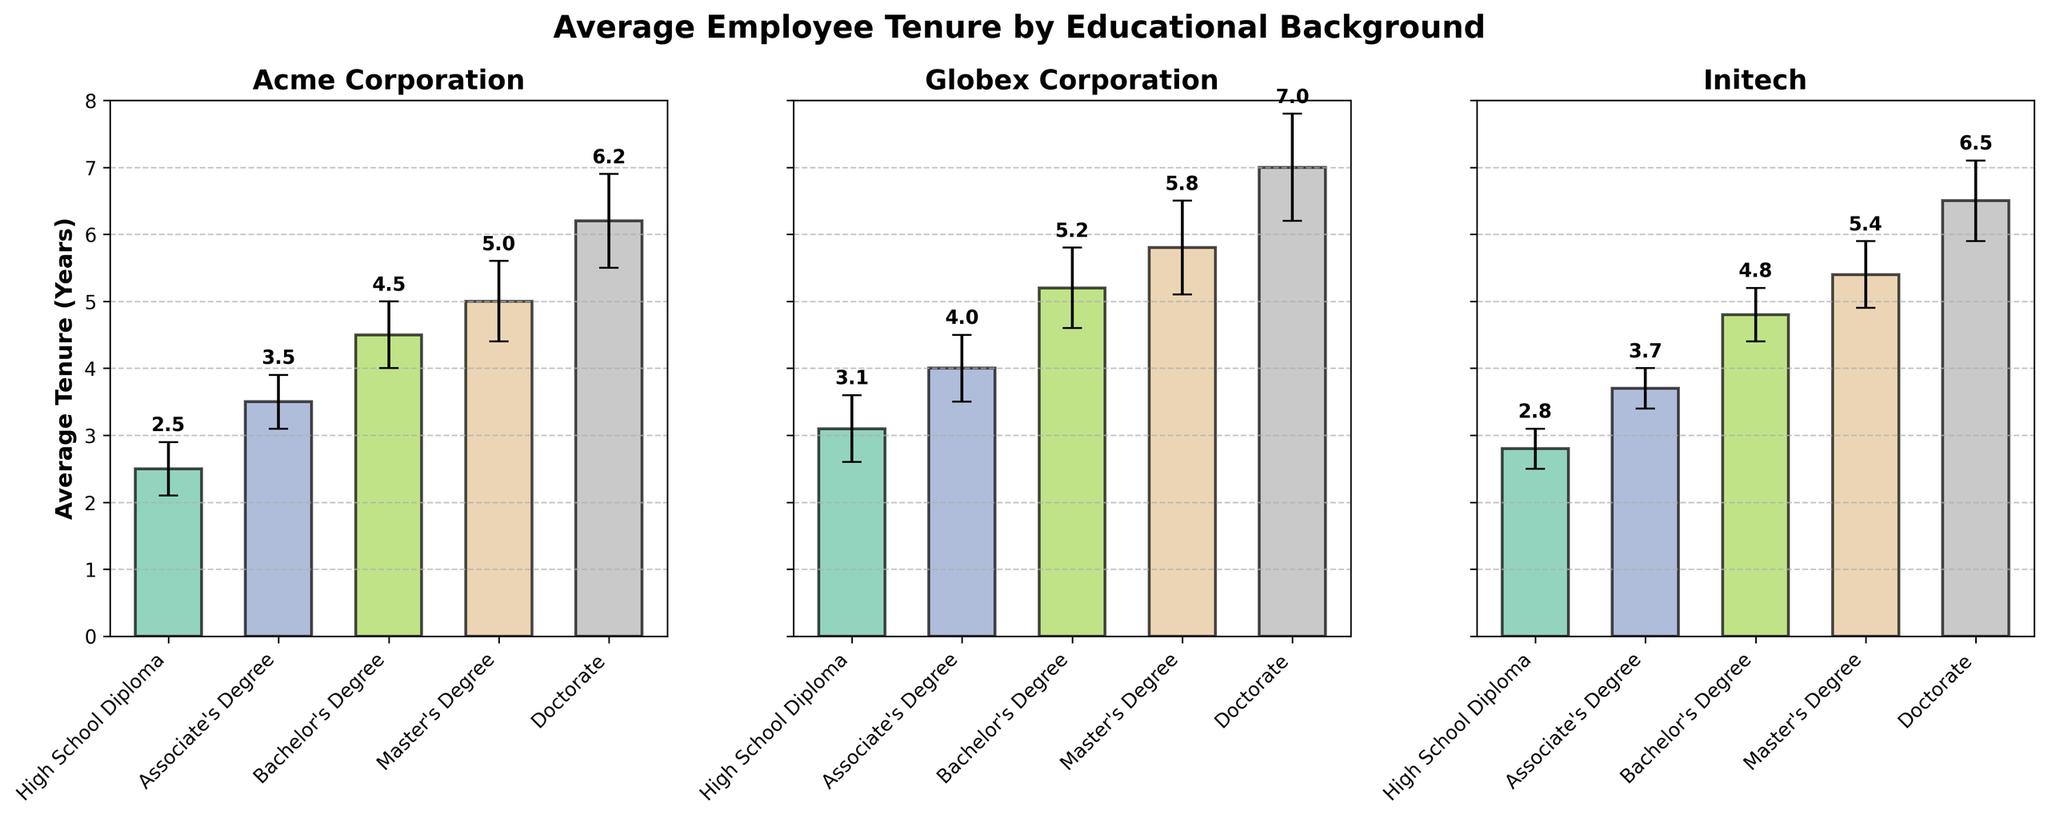What is the title of the figure? The title is usually displayed at the top of the figure or subplot and often summarizes the main information being presented.
Answer: Average Employee Tenure by Educational Background Which company has the highest average employee tenure for a Bachelor's Degree? By examining the error bars for the Bachelor's Degree category across companies, the highest bar corresponds to Globex Corporation.
Answer: Globex Corporation What is the average employee tenure for a Doctorate Degree at Initech? Locate the bar corresponding to the Doctorate Degree at Initech and read the label or estimate the height of the bar.
Answer: 6.5 years Across all companies, which education level tends to have the shortest average tenure? Compare the height of the bars across the different education levels for each subplot and find the education level that consistently has the shortest bars.
Answer: High School Diploma What is the difference in average employee tenure between a Master's Degree and a Bachelor's Degree for Acme Corporation? Subtract the average tenure of a Bachelor's Degree from that of a Master's Degree for Acme Corporation, as indicated by the bar heights.
Answer: 0.5 years What is the confidence interval range for the employees with a Master's Degree at Globex Corporation? Identify the y-axis error bar for the Master's Degree at Globex Corporation and read the value.
Answer: ± 0.7 years Which company shows the largest variation in average employee tenure across all education levels? Compare the range of bar heights across all education levels for each company to identify the one with the largest difference between its highest and lowest bars.
Answer: Globex Corporation How many companies are compared in this figure? Count the number of subplots or separate groupings of bars in the figure.
Answer: 3 Is there any education level where Acme Corporation's average tenure exceeds 6 years? Locate the bars for Acme Corporation and check if any of them exceed the 6-year mark on the y-axis.
Answer: Yes (Doctorate) By how much does the confidence interval for a Doctorate Degree at Globex Corporation exceed that of an Associate's Degree at Initech? Subtract the confidence interval value of an Associate's Degree at Initech from that of a Doctorate Degree at Globex Corporation.
Answer: 0.5 years 